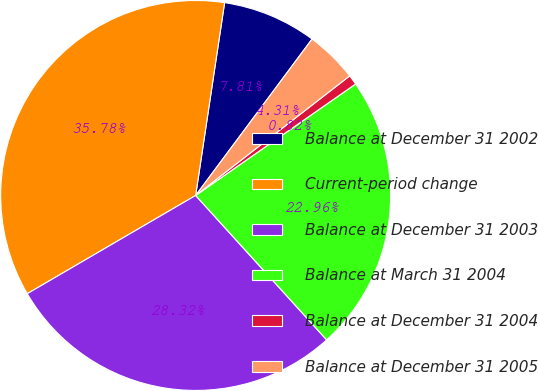Convert chart. <chart><loc_0><loc_0><loc_500><loc_500><pie_chart><fcel>Balance at December 31 2002<fcel>Current-period change<fcel>Balance at December 31 2003<fcel>Balance at March 31 2004<fcel>Balance at December 31 2004<fcel>Balance at December 31 2005<nl><fcel>7.81%<fcel>35.78%<fcel>28.32%<fcel>22.96%<fcel>0.82%<fcel>4.31%<nl></chart> 